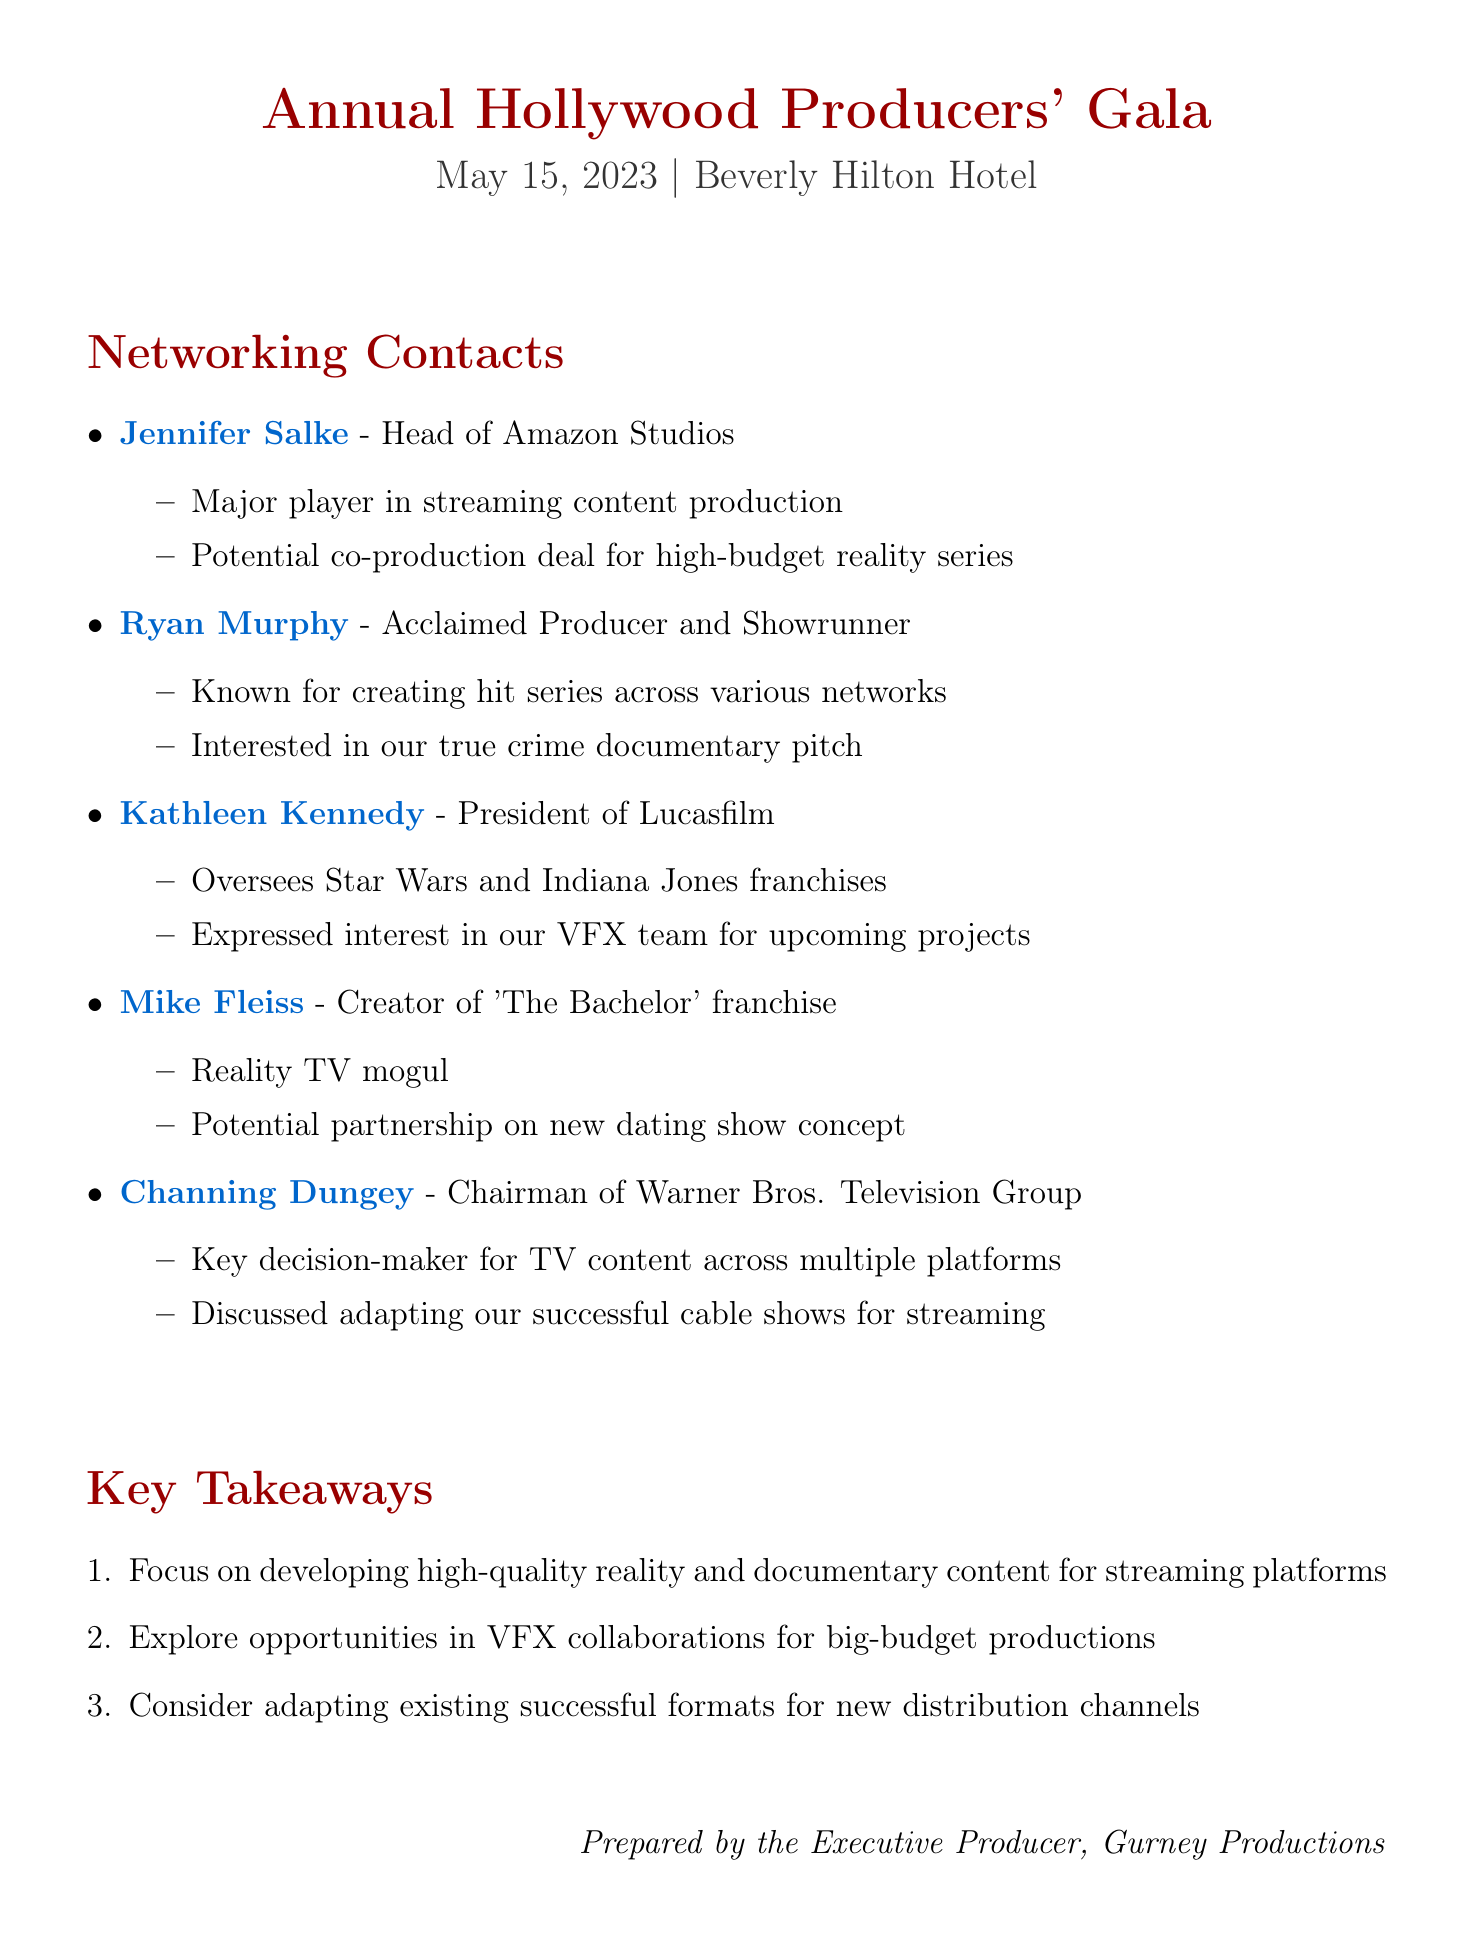What is the name of the event? The name of the event is stated in the document as the main title.
Answer: Annual Hollywood Producers' Gala When did the event take place? The date of the event is specified in the document.
Answer: May 15, 2023 Who is the Head of Amazon Studios? The document lists Jennifer Salke as the Head of Amazon Studios.
Answer: Jennifer Salke What is Ryan Murphy known for? The document describes Ryan Murphy's influence and achievements.
Answer: Creating hit series What potential collaboration was discussed with Jennifer Salke? The collaboration potential mentioned in the document refers to a specific type of project.
Answer: Co-production deal for high-budget reality series Which franchise does Kathleen Kennedy oversee? The document indicates Kathleen Kennedy's significant role and the franchises she oversees.
Answer: Star Wars and Indiana Jones What type of content does Channing Dungey focus on? The role of Channing Dungey and her influence is highlighted in the document.
Answer: TV content How many key takeaways are mentioned in the document? The document lists the number of key takeaways under a specific section.
Answer: Three What opportunity was discussed with Mike Fleiss? The document offers insights into the collaboration potential with Mike Fleiss.
Answer: New dating show concept What is the venue of the event? The venue of the event is mentioned in a specific section of the document.
Answer: Beverly Hilton Hotel 